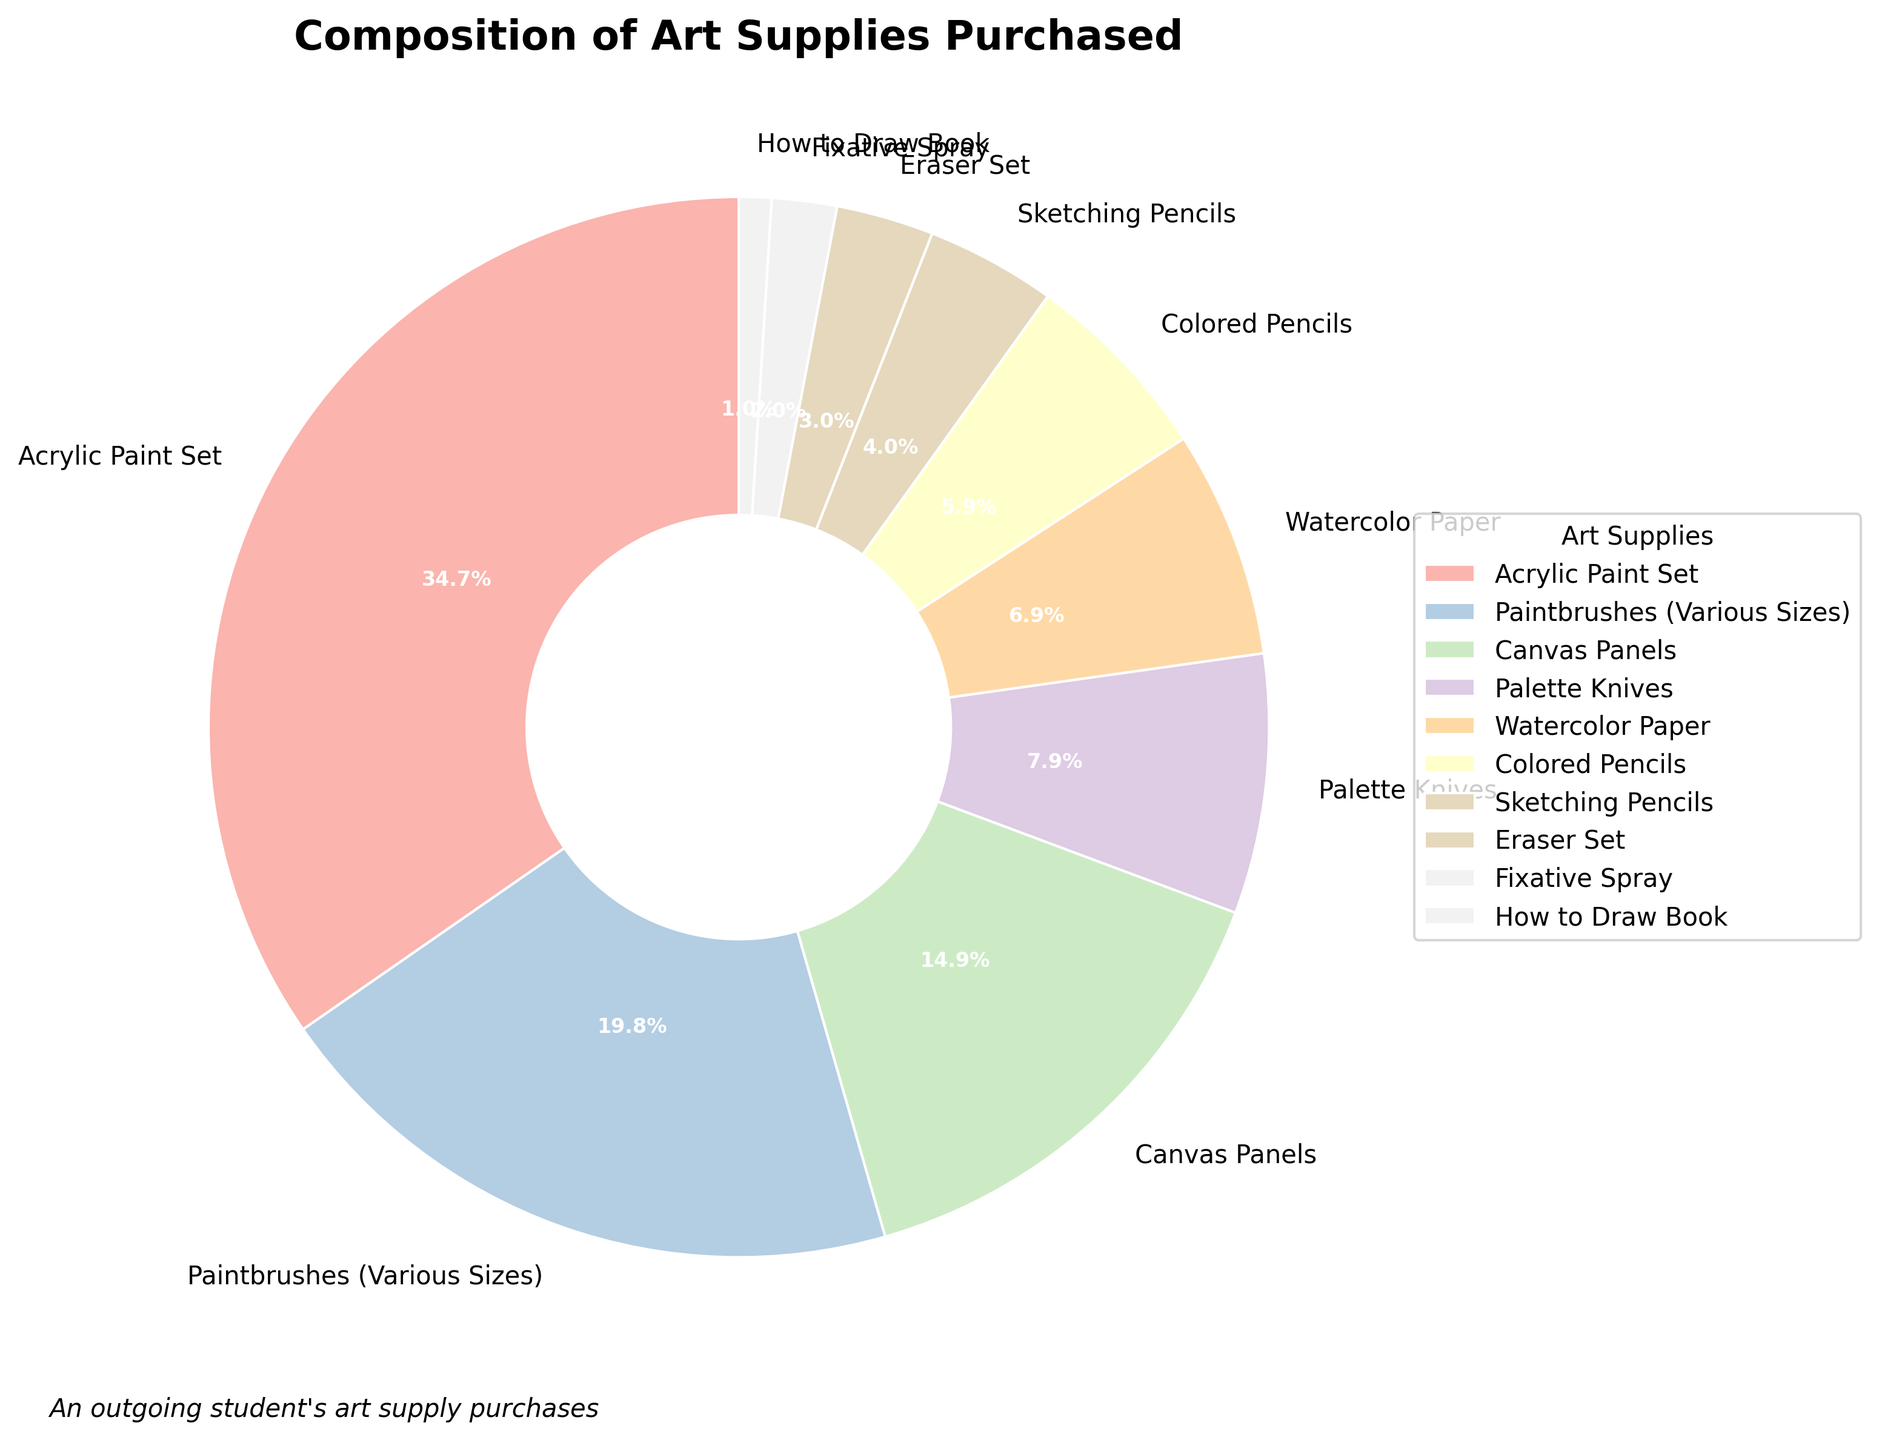what are the three most purchased items? To determine the three most purchased items, look at the percentages of each item in the pie chart. Identify the items with the highest percentages. The top three are "Acrylic Paint Set" (35%), "Paintbrushes (Various Sizes)" (20%), and "Canvas Panels" (15%).
Answer: Acrylic Paint Set, Paintbrushes, Canvas Panels What is the total percentage of items related to drawing (Colored Pencils, Sketching Pencils, and Eraser Set)? Add the percentages for "Colored Pencils" (6%), "Sketching Pencils" (4%), and "Eraser Set" (3%). Sum = 6 + 4 + 3 = 13%.
Answer: 13% Which item has the smallest percentage and how much is it? Look for the item with the smallest percentage in the pie chart. The "How to Draw" Book has the smallest percentage at 1%.
Answer: How to Draw Book, 1% Is the percentage of Paintbrushes greater than the combined percentage of the Watercolor Paper and Colored Pencils? Compare the percentage of Paintbrushes (20%) to the combined percentage of Watercolor Paper (7%) and Colored Pencils (6%). Combined percentage = 7 + 6 = 13%. Since 20% is greater than 13%, the percentage of Paintbrushes is greater.
Answer: Yes How do the percentages of Canvas Panels and Palette Knives compare? Compare the percentages of Canvas Panels (15%) and Palette Knives (8%). By subtraction, 15 - 8 = 7%, meaning Canvas Panels are 7% higher than Palette Knives.
Answer: Canvas Panels are higher Which item occupies more space visually in the chart, Eraser Set or Fixative Spray? Visually inspect the pie chart slices for Eraser Set and Fixative Spray. The Eraser Set (3%) occupies more space than the Fixative Spray (2%).
Answer: Eraser Set What is the combined percentage of all painting-related items (Acrylic Paint Set, Paintbrushes, Canvas Panels, Palette Knives, Watercolor Paper)? Sum the percentages for painting-related items: "Acrylic Paint Set" (35%), "Paintbrushes" (20%), "Canvas Panels" (15%), "Palette Knives" (8%), and "Watercolor Paper" (7%). Total = 35 + 20 + 15 + 8 + 7 = 85%.
Answer: 85% Which two items have a combined percentage that is closest to 10%? Identify the items whose combined percentages are closest to 10%. "Watercolor Paper" (7%) and "Fixative Spray" (2%) together add up to 9%, which is closest to 10%.
Answer: Watercolor Paper, Fixative Spray Identify the median percentage value from the listed items and name the item that corresponds to it. List the percentages in ascending order: "How to Draw" Book (1%), Fixative Spray (2%), Eraser Set (3%), Sketching Pencils (4%), Colored Pencils (6%), Watercolor Paper (7%), Palette Knives (8%), Canvas Panels (15%), Paintbrushes (20%), Acrylic Paint Set (35%). The median is the middle value, which is Colored Pencils at 6%.
Answer: Colored Pencils, 6% 